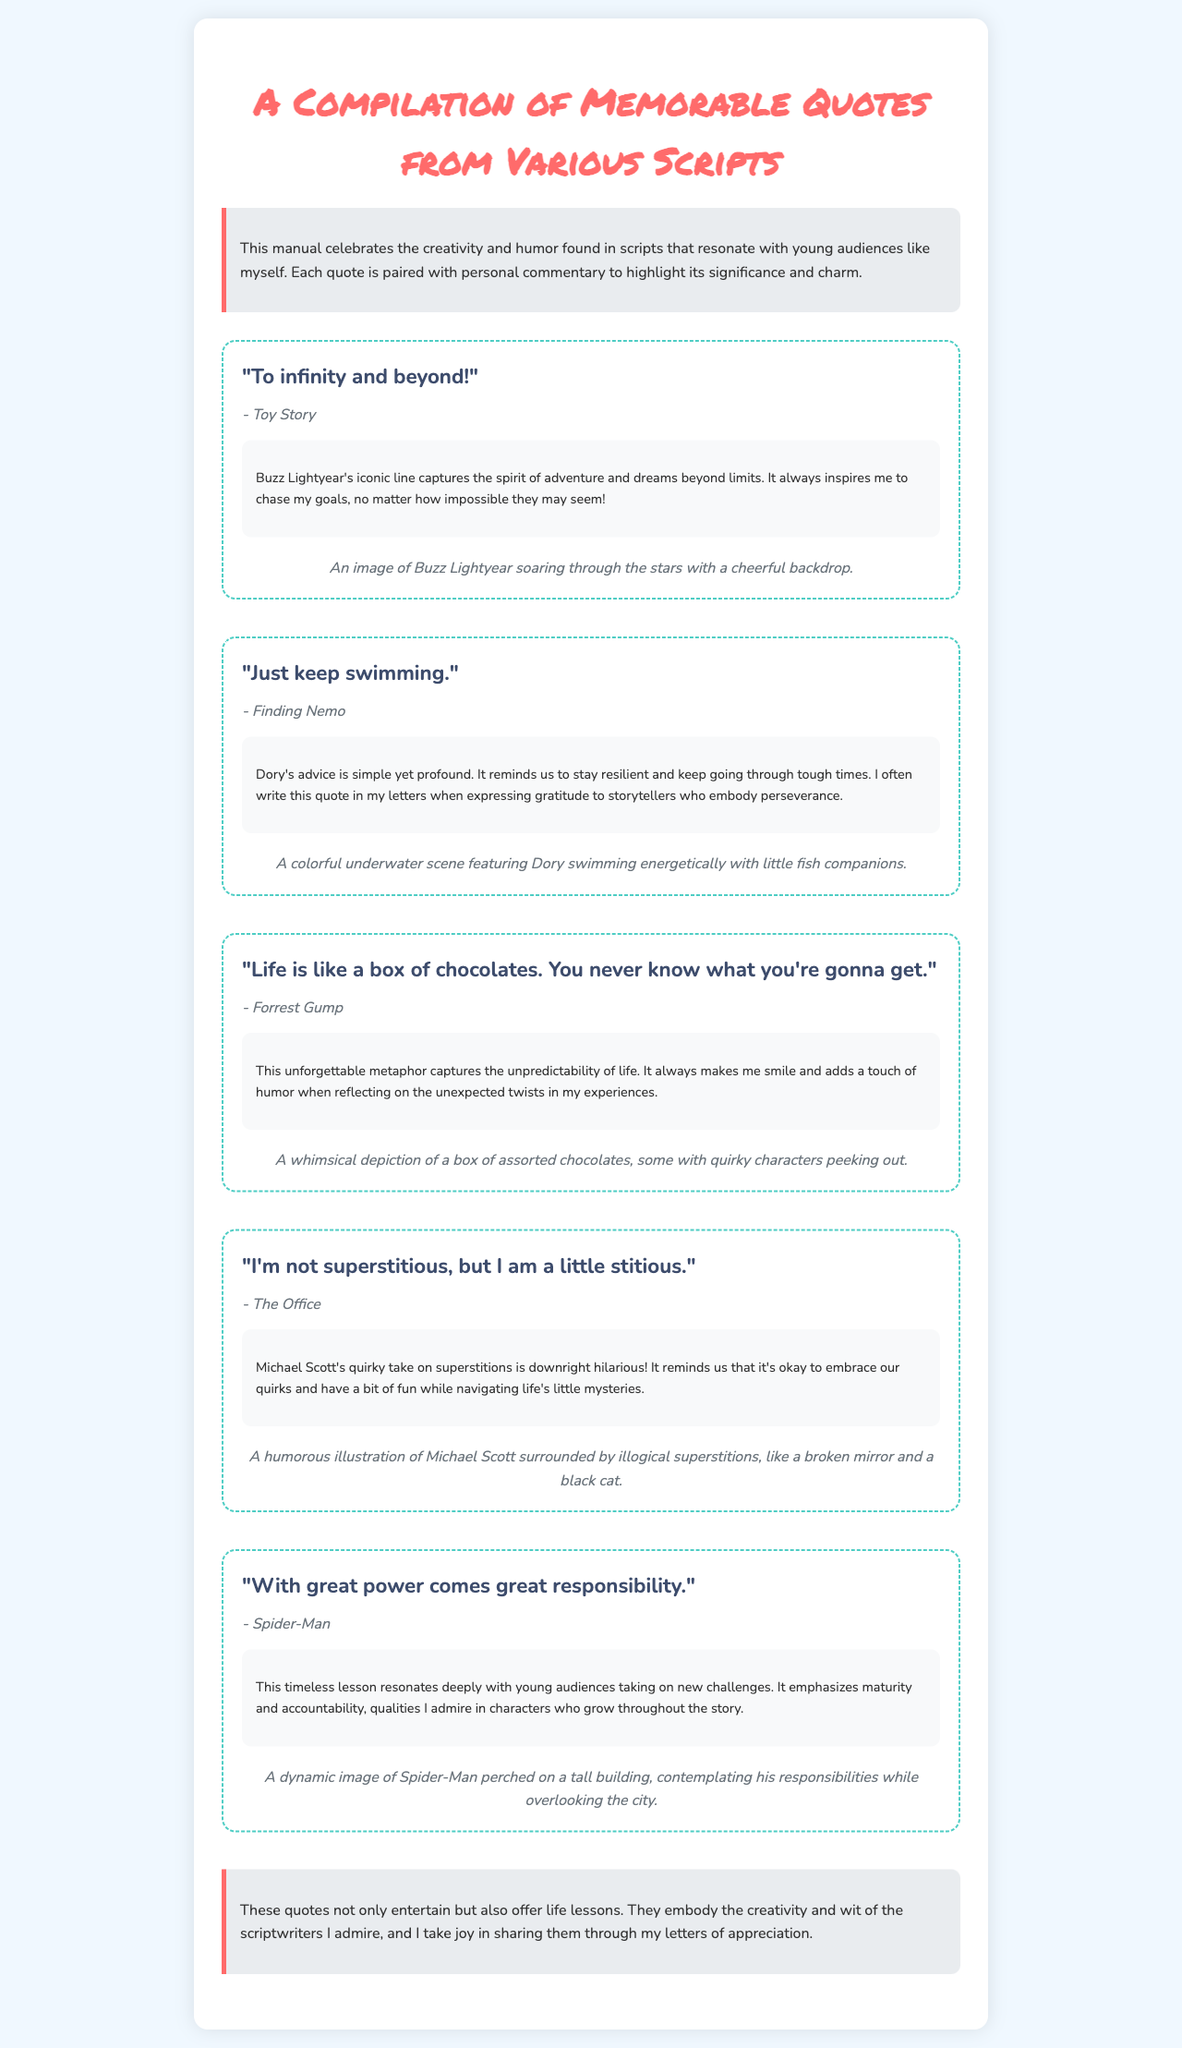what is the title of the document? The title is prominently displayed at the top and reads, "A Compilation of Memorable Quotes from Various Scripts."
Answer: A Compilation of Memorable Quotes from Various Scripts who says the quote "To infinity and beyond!"? This quote is attributed to a character in the animated film Toy Story.
Answer: Buzz Lightyear how many quotes are featured in the document? The document includes five distinct quotes from various scripts.
Answer: Five what does Dory say in Finding Nemo? The document quotes Dory's advice, which is well-known and motivational.
Answer: Just keep swimming which quote emphasizes the importance of responsibility? This quote is associated with a superhero character and conveys a significant lesson about maturity.
Answer: With great power comes great responsibility which film is the source of the quote "Life is like a box of chocolates"? The document attributes this famous quote to a very popular film that also includes themes of life’s unpredictability.
Answer: Forrest Gump what is the main theme highlighted in the quotes? The document reflects on attributes like perseverance, humor, and personal growth conveyed through the quotes.
Answer: Life lessons who is associated with the humorous quote about superstition? The document references a character known for his unique and comical perspective on life.
Answer: Michael Scott 